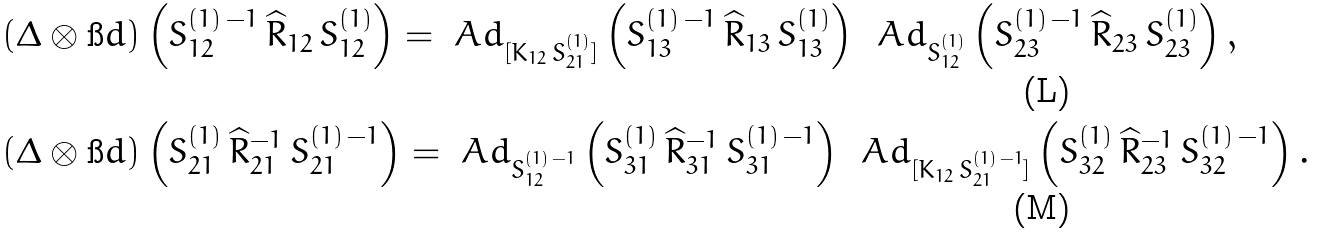<formula> <loc_0><loc_0><loc_500><loc_500>& ( \Delta \otimes \i d ) \left ( S ^ { ( 1 ) \, - 1 } _ { 1 2 } \, \widehat { R } _ { 1 2 } \, S ^ { ( 1 ) } _ { 1 2 } \right ) = \ A d _ { [ K _ { 1 2 } \, S ^ { ( 1 ) } _ { 2 1 } ] } \left ( S ^ { ( 1 ) \, - 1 } _ { 1 3 } \, \widehat { R } _ { 1 3 } \, S ^ { ( 1 ) } _ { 1 3 } \right ) \, \ A d _ { S ^ { ( 1 ) } _ { 1 2 } } \left ( S ^ { ( 1 ) \, - 1 } _ { 2 3 } \, \widehat { R } _ { 2 3 } \, S ^ { ( 1 ) } _ { 2 3 } \right ) , \\ & ( \Delta \otimes \i d ) \left ( S ^ { ( 1 ) } _ { 2 1 } \, \widehat { R } ^ { - 1 } _ { 2 1 } \, S ^ { ( 1 ) \, - 1 } _ { 2 1 } \right ) = \ A d _ { S ^ { ( 1 ) \, - 1 } _ { 1 2 } } \left ( S ^ { ( 1 ) } _ { 3 1 } \, \widehat { R } ^ { - 1 } _ { 3 1 } \, S ^ { ( 1 ) \, - 1 } _ { 3 1 } \right ) \, \ A d _ { [ K _ { 1 2 } \, S ^ { ( 1 ) \, - 1 } _ { 2 1 } ] } \left ( S ^ { ( 1 ) } _ { 3 2 } \, \widehat { R } ^ { - 1 } _ { 2 3 } \, S ^ { ( 1 ) \, - 1 } _ { 3 2 } \right ) .</formula> 